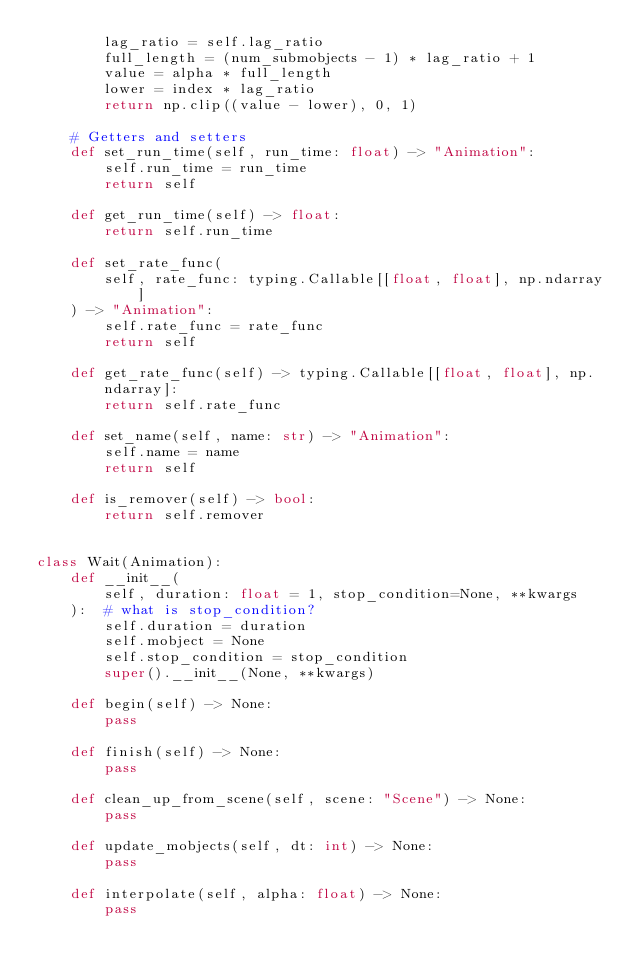<code> <loc_0><loc_0><loc_500><loc_500><_Python_>        lag_ratio = self.lag_ratio
        full_length = (num_submobjects - 1) * lag_ratio + 1
        value = alpha * full_length
        lower = index * lag_ratio
        return np.clip((value - lower), 0, 1)

    # Getters and setters
    def set_run_time(self, run_time: float) -> "Animation":
        self.run_time = run_time
        return self

    def get_run_time(self) -> float:
        return self.run_time

    def set_rate_func(
        self, rate_func: typing.Callable[[float, float], np.ndarray]
    ) -> "Animation":
        self.rate_func = rate_func
        return self

    def get_rate_func(self) -> typing.Callable[[float, float], np.ndarray]:
        return self.rate_func

    def set_name(self, name: str) -> "Animation":
        self.name = name
        return self

    def is_remover(self) -> bool:
        return self.remover


class Wait(Animation):
    def __init__(
        self, duration: float = 1, stop_condition=None, **kwargs
    ):  # what is stop_condition?
        self.duration = duration
        self.mobject = None
        self.stop_condition = stop_condition
        super().__init__(None, **kwargs)

    def begin(self) -> None:
        pass

    def finish(self) -> None:
        pass

    def clean_up_from_scene(self, scene: "Scene") -> None:
        pass

    def update_mobjects(self, dt: int) -> None:
        pass

    def interpolate(self, alpha: float) -> None:
        pass
</code> 